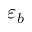<formula> <loc_0><loc_0><loc_500><loc_500>\varepsilon _ { b }</formula> 